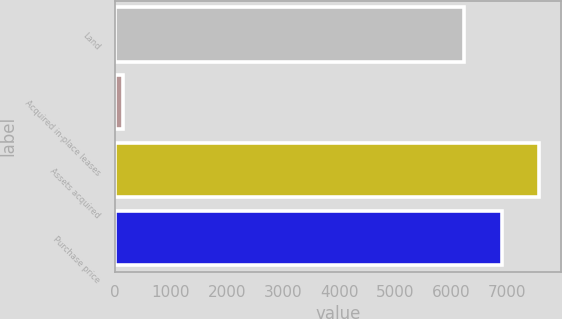Convert chart. <chart><loc_0><loc_0><loc_500><loc_500><bar_chart><fcel>Land<fcel>Acquired in-place leases<fcel>Assets acquired<fcel>Purchase price<nl><fcel>6226<fcel>146<fcel>7571.4<fcel>6898.7<nl></chart> 